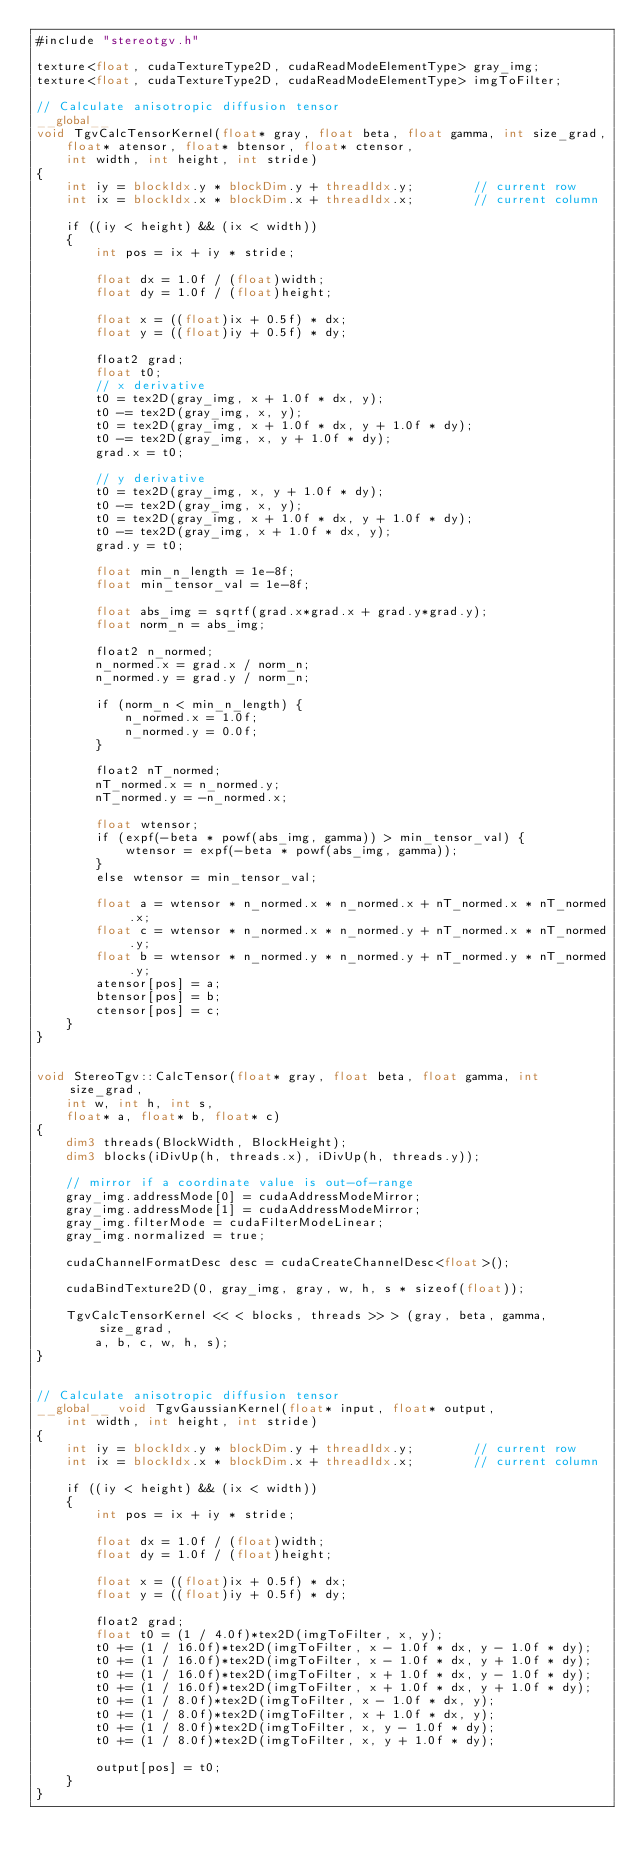Convert code to text. <code><loc_0><loc_0><loc_500><loc_500><_Cuda_>#include "stereotgv.h"

texture<float, cudaTextureType2D, cudaReadModeElementType> gray_img;
texture<float, cudaTextureType2D, cudaReadModeElementType> imgToFilter;

// Calculate anisotropic diffusion tensor
__global__ 
void TgvCalcTensorKernel(float* gray, float beta, float gamma, int size_grad,
	float* atensor, float* btensor, float* ctensor,
	int width, int height, int stride)
{
	int iy = blockIdx.y * blockDim.y + threadIdx.y;        // current row 
	int ix = blockIdx.x * blockDim.x + threadIdx.x;        // current column 

	if ((iy < height) && (ix < width))
	{
		int pos = ix + iy * stride;

		float dx = 1.0f / (float)width;
		float dy = 1.0f / (float)height;

		float x = ((float)ix + 0.5f) * dx;
		float y = ((float)iy + 0.5f) * dy;

		float2 grad;
		float t0;
		// x derivative
		t0 = tex2D(gray_img, x + 1.0f * dx, y);
		t0 -= tex2D(gray_img, x, y);
		t0 = tex2D(gray_img, x + 1.0f * dx, y + 1.0f * dy);
		t0 -= tex2D(gray_img, x, y + 1.0f * dy);
		grad.x = t0;

		// y derivative
		t0 = tex2D(gray_img, x, y + 1.0f * dy);
		t0 -= tex2D(gray_img, x, y);
		t0 = tex2D(gray_img, x + 1.0f * dx, y + 1.0f * dy);
		t0 -= tex2D(gray_img, x + 1.0f * dx, y);
		grad.y = t0;

		float min_n_length = 1e-8f;
		float min_tensor_val = 1e-8f;

		float abs_img = sqrtf(grad.x*grad.x + grad.y*grad.y);
		float norm_n = abs_img;

		float2 n_normed;
		n_normed.x = grad.x / norm_n;
		n_normed.y = grad.y / norm_n;

		if (norm_n < min_n_length) {
			n_normed.x = 1.0f;
			n_normed.y = 0.0f;
		}

		float2 nT_normed;
		nT_normed.x = n_normed.y;
		nT_normed.y = -n_normed.x;

		float wtensor;
		if (expf(-beta * powf(abs_img, gamma)) > min_tensor_val) {
			wtensor = expf(-beta * powf(abs_img, gamma));
		}
		else wtensor = min_tensor_val;

		float a = wtensor * n_normed.x * n_normed.x + nT_normed.x * nT_normed.x;
		float c = wtensor * n_normed.x * n_normed.y + nT_normed.x * nT_normed.y;
		float b = wtensor * n_normed.y * n_normed.y + nT_normed.y * nT_normed.y;
		atensor[pos] = a;
		btensor[pos] = b;
		ctensor[pos] = c;
	}
}


void StereoTgv::CalcTensor(float* gray, float beta, float gamma, int size_grad,
	int w, int h, int s,
	float* a, float* b, float* c)
{
	dim3 threads(BlockWidth, BlockHeight);
	dim3 blocks(iDivUp(h, threads.x), iDivUp(h, threads.y));

	// mirror if a coordinate value is out-of-range
	gray_img.addressMode[0] = cudaAddressModeMirror;
	gray_img.addressMode[1] = cudaAddressModeMirror;
	gray_img.filterMode = cudaFilterModeLinear;
	gray_img.normalized = true;

	cudaChannelFormatDesc desc = cudaCreateChannelDesc<float>();

	cudaBindTexture2D(0, gray_img, gray, w, h, s * sizeof(float));

	TgvCalcTensorKernel << < blocks, threads >> > (gray, beta, gamma, size_grad,
		a, b, c, w, h, s);
}


// Calculate anisotropic diffusion tensor
__global__ void TgvGaussianKernel(float* input, float* output,
	int width, int height, int stride)
{
	int iy = blockIdx.y * blockDim.y + threadIdx.y;        // current row 
	int ix = blockIdx.x * blockDim.x + threadIdx.x;        // current column 

	if ((iy < height) && (ix < width))
	{
		int pos = ix + iy * stride;

		float dx = 1.0f / (float)width;
		float dy = 1.0f / (float)height;

		float x = ((float)ix + 0.5f) * dx;
		float y = ((float)iy + 0.5f) * dy;

		float2 grad;
		float t0 = (1 / 4.0f)*tex2D(imgToFilter, x, y);
		t0 += (1 / 16.0f)*tex2D(imgToFilter, x - 1.0f * dx, y - 1.0f * dy);
		t0 += (1 / 16.0f)*tex2D(imgToFilter, x - 1.0f * dx, y + 1.0f * dy);
		t0 += (1 / 16.0f)*tex2D(imgToFilter, x + 1.0f * dx, y - 1.0f * dy);
		t0 += (1 / 16.0f)*tex2D(imgToFilter, x + 1.0f * dx, y + 1.0f * dy);
		t0 += (1 / 8.0f)*tex2D(imgToFilter, x - 1.0f * dx, y);
		t0 += (1 / 8.0f)*tex2D(imgToFilter, x + 1.0f * dx, y);
		t0 += (1 / 8.0f)*tex2D(imgToFilter, x, y - 1.0f * dy);
		t0 += (1 / 8.0f)*tex2D(imgToFilter, x, y + 1.0f * dy);

		output[pos] = t0;
	}
}

</code> 